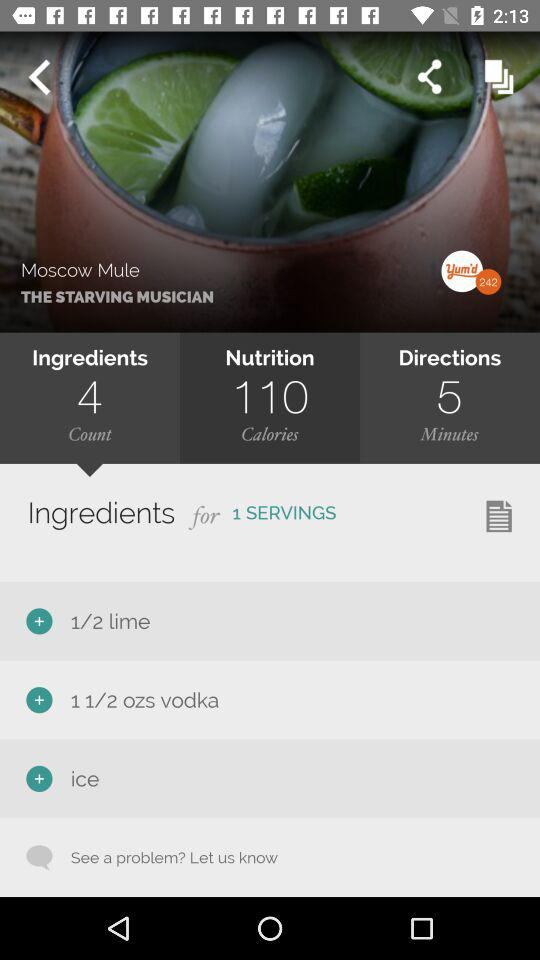How much time will it take to make? The time is 5 minutes. 